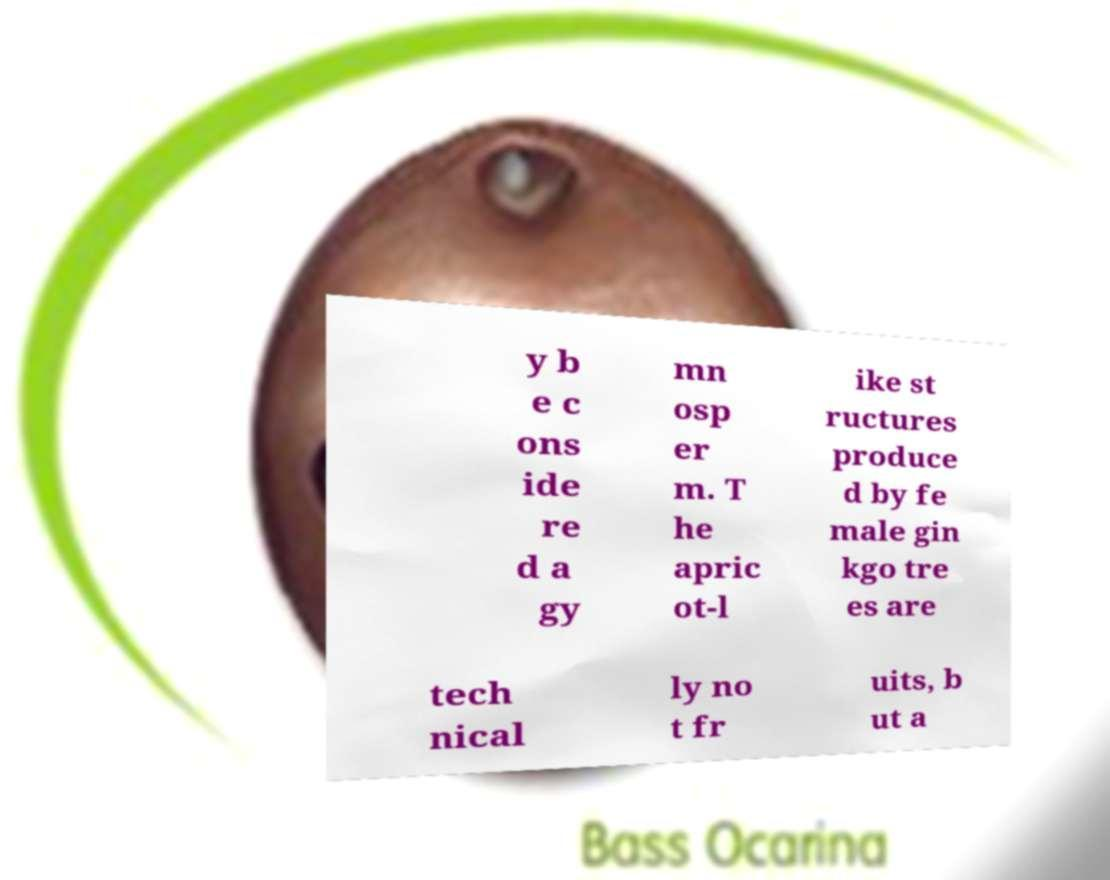For documentation purposes, I need the text within this image transcribed. Could you provide that? y b e c ons ide re d a gy mn osp er m. T he apric ot-l ike st ructures produce d by fe male gin kgo tre es are tech nical ly no t fr uits, b ut a 